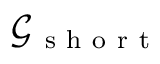Convert formula to latex. <formula><loc_0><loc_0><loc_500><loc_500>\mathcal { G _ { s h o r t } }</formula> 